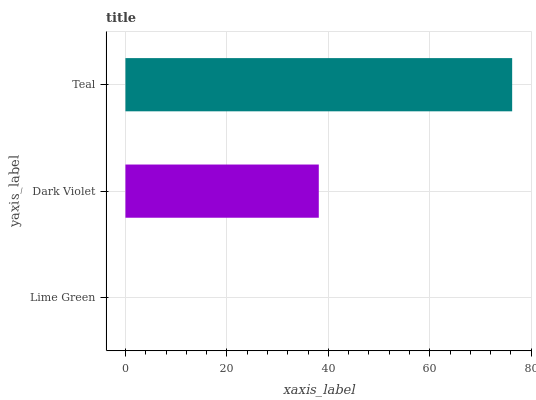Is Lime Green the minimum?
Answer yes or no. Yes. Is Teal the maximum?
Answer yes or no. Yes. Is Dark Violet the minimum?
Answer yes or no. No. Is Dark Violet the maximum?
Answer yes or no. No. Is Dark Violet greater than Lime Green?
Answer yes or no. Yes. Is Lime Green less than Dark Violet?
Answer yes or no. Yes. Is Lime Green greater than Dark Violet?
Answer yes or no. No. Is Dark Violet less than Lime Green?
Answer yes or no. No. Is Dark Violet the high median?
Answer yes or no. Yes. Is Dark Violet the low median?
Answer yes or no. Yes. Is Lime Green the high median?
Answer yes or no. No. Is Lime Green the low median?
Answer yes or no. No. 